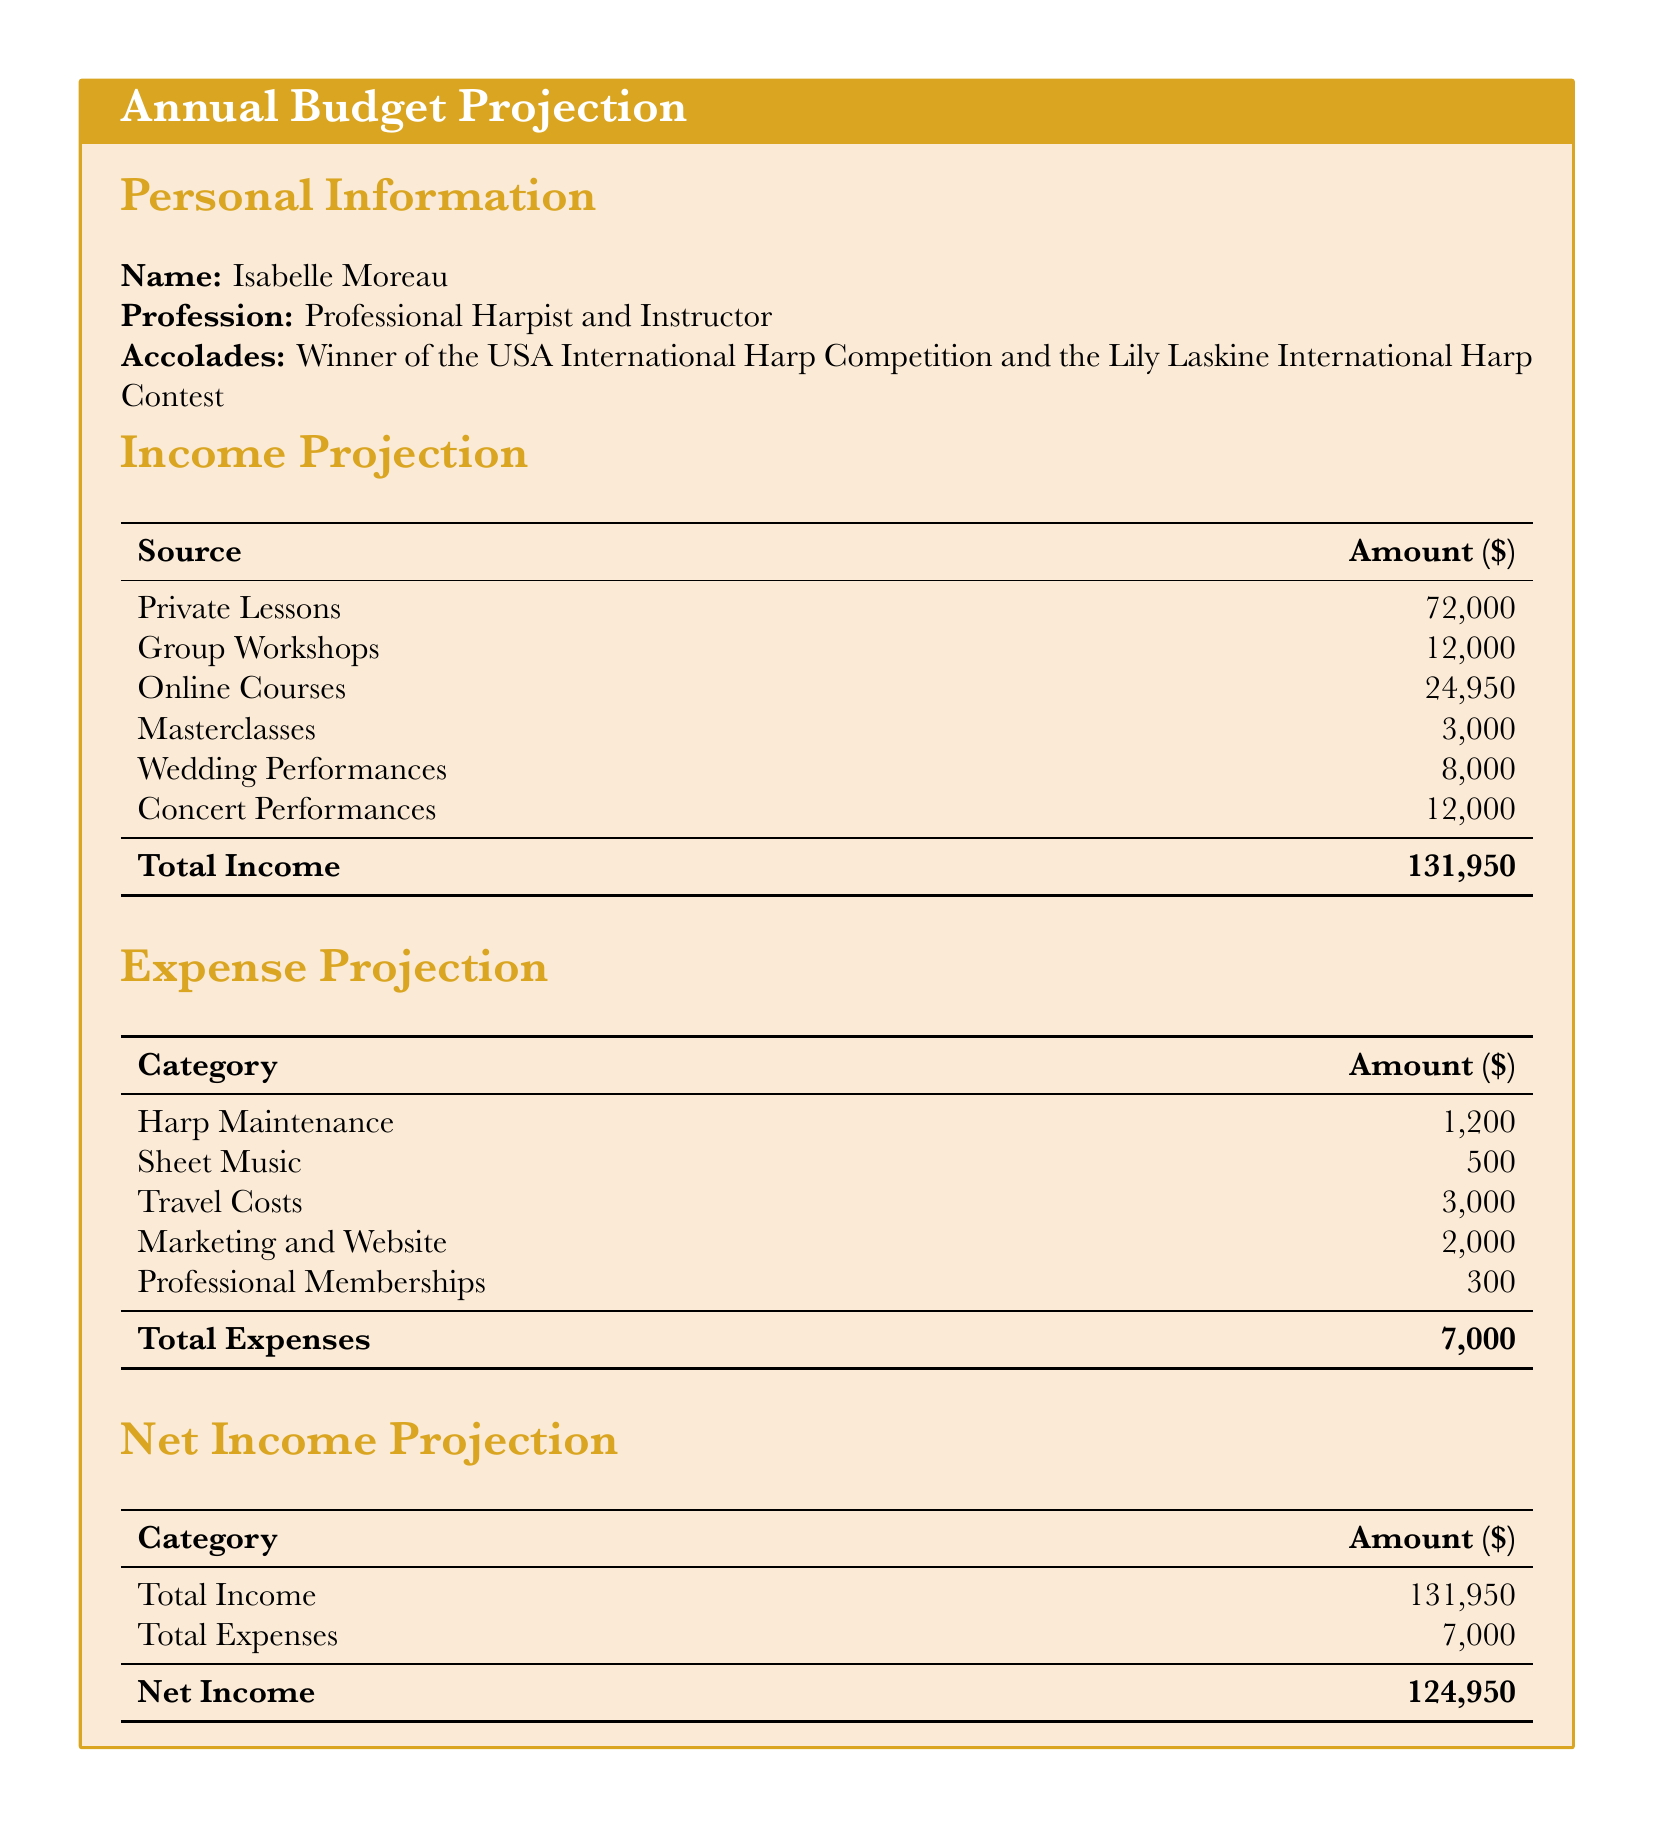What is the total income projection? The total income projection is calculated by adding all sources of income listed in the document.
Answer: 131,950 How much is earned from private lessons? The document specifies that income from private lessons is one of the main sources listed.
Answer: 72,000 What is the expense for harp maintenance? The document provides a breakdown of expenses, including harp maintenance costs.
Answer: 1,200 What is the net income? The net income is derived by subtracting total expenses from total income.
Answer: 124,950 What is the amount earned from online courses? The document lists online courses as a source of income with a specified amount.
Answer: 24,950 What is the total amount spent on travel costs? The travel costs are clearly outlined in the expenses section of the document.
Answer: 3,000 How much revenue is generated from concert performances? The document notes the revenue generated specifically from concert performances as one of the sources.
Answer: 12,000 What is the budget category with the smallest expense? The document lists several expense categories, and the smallest one can be identified from these.
Answer: 300 How many sources of income are listed in the document? The total number of sources of income can be counted from the income projection section.
Answer: 6 What is the total amount allocated for marketing and website? The document specifies the amount designated for marketing and website expenses.
Answer: 2,000 